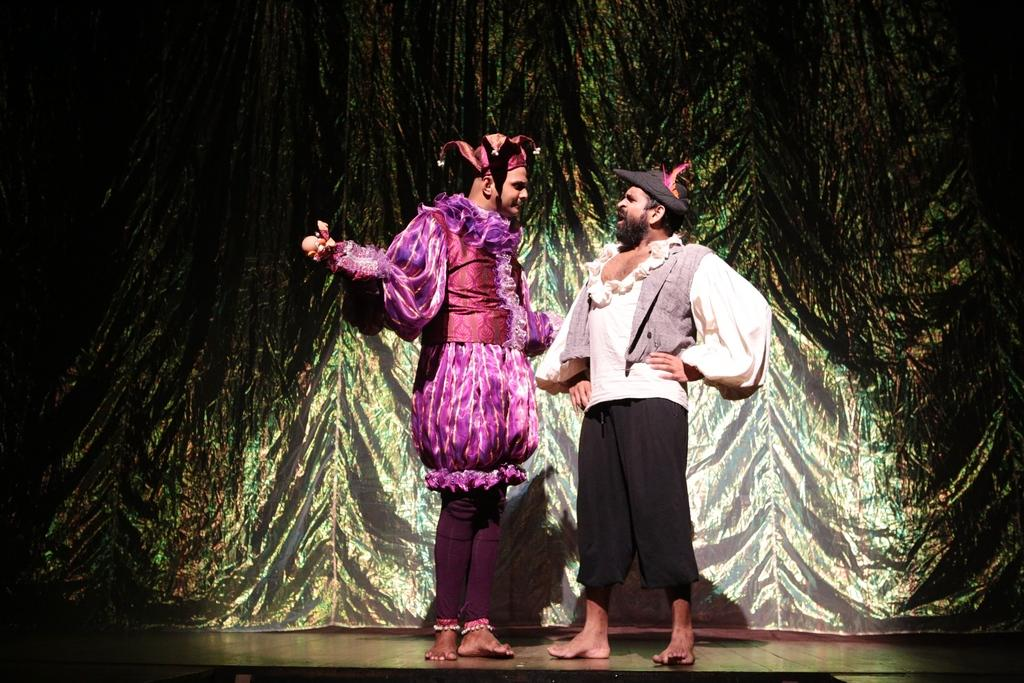How many people are present in the image? There are two persons standing in the image. What can be seen in the background of the image? There is a curtain in the background of the image. Is there any special lighting on the persons in the image? Yes, there is a spotlight on one or both of the persons. What type of coat is the queen wearing in the image? There is no queen or coat present in the image. 